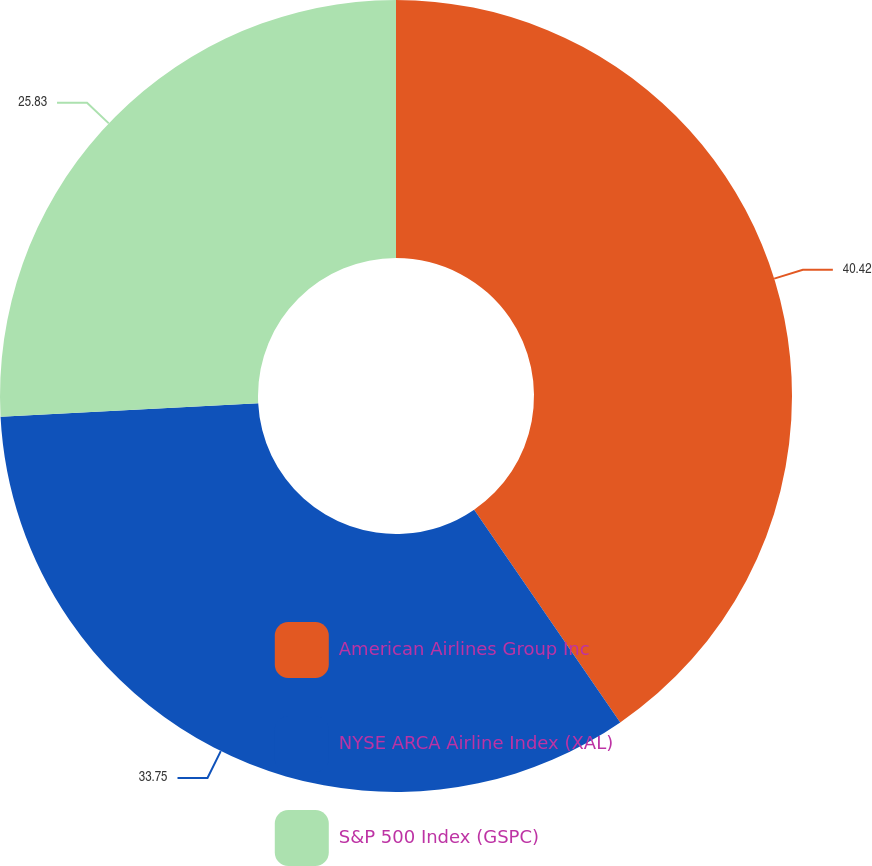Convert chart. <chart><loc_0><loc_0><loc_500><loc_500><pie_chart><fcel>American Airlines Group Inc<fcel>NYSE ARCA Airline Index (XAL)<fcel>S&P 500 Index (GSPC)<nl><fcel>40.42%<fcel>33.75%<fcel>25.83%<nl></chart> 